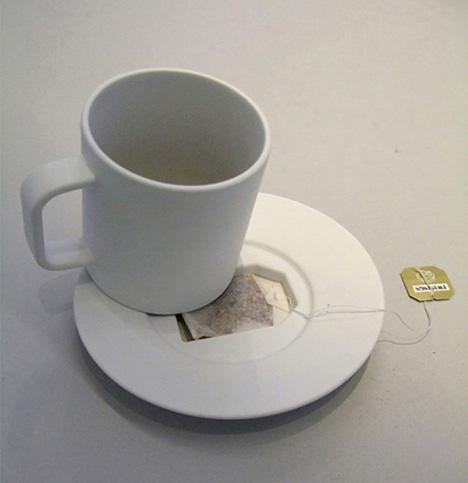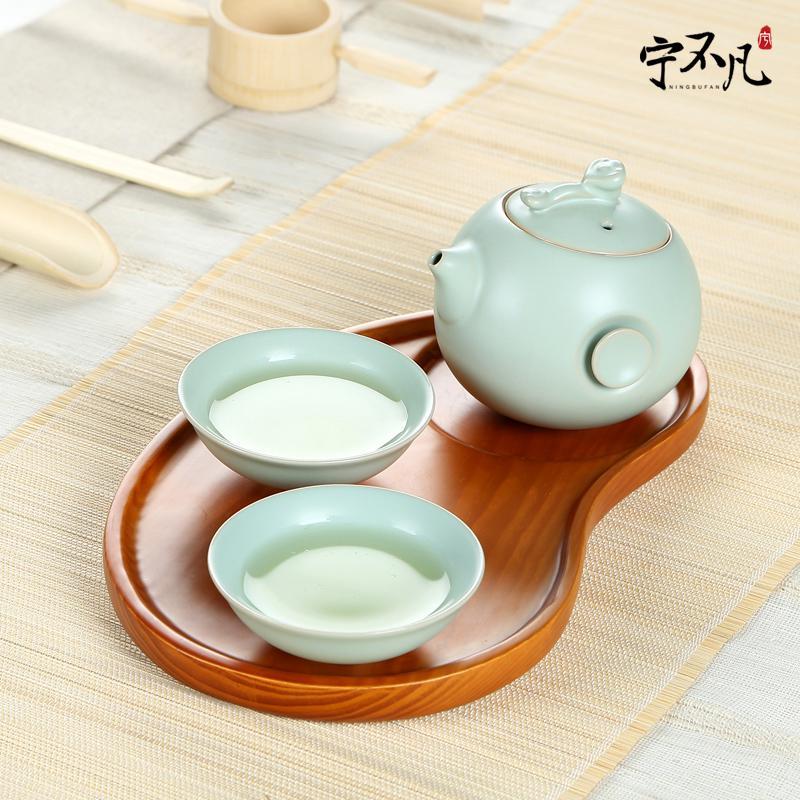The first image is the image on the left, the second image is the image on the right. Examine the images to the left and right. Is the description "An image shows one light-colored cup on top of a matching saucer." accurate? Answer yes or no. Yes. The first image is the image on the left, the second image is the image on the right. For the images displayed, is the sentence "There are two saucers in total, each holding a coffee cup." factually correct? Answer yes or no. No. 